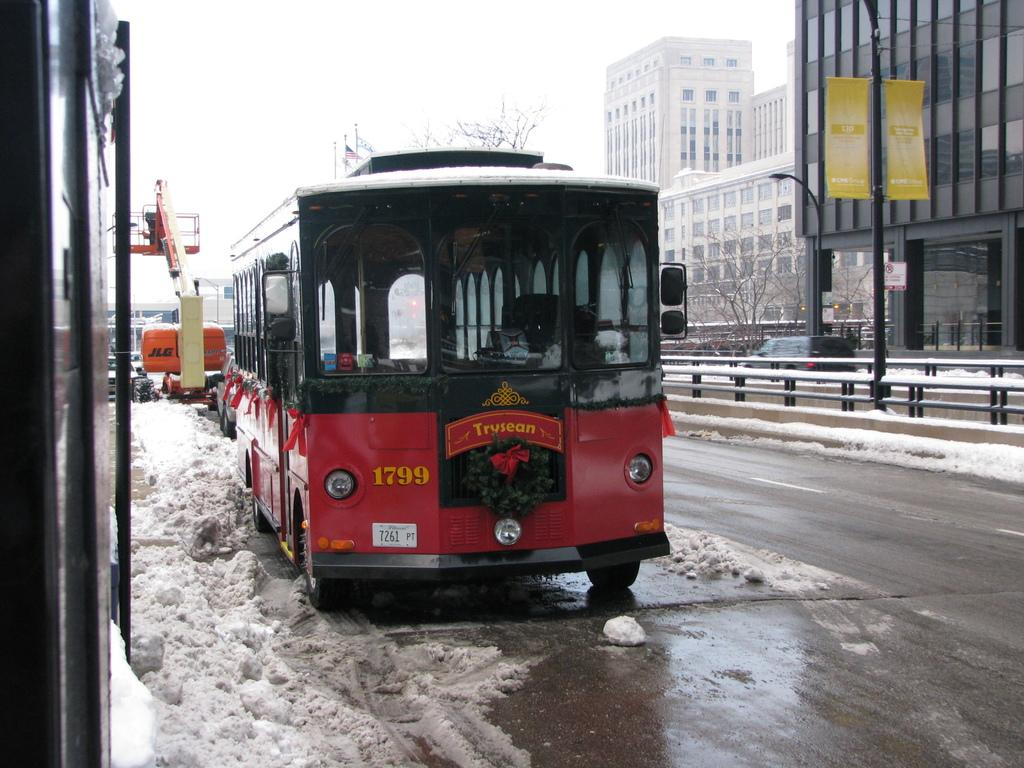<image>
Summarize the visual content of the image. Trolley number 1799 is parked on the side of a snowy sidewalk, red ribbons tied by the windows. 